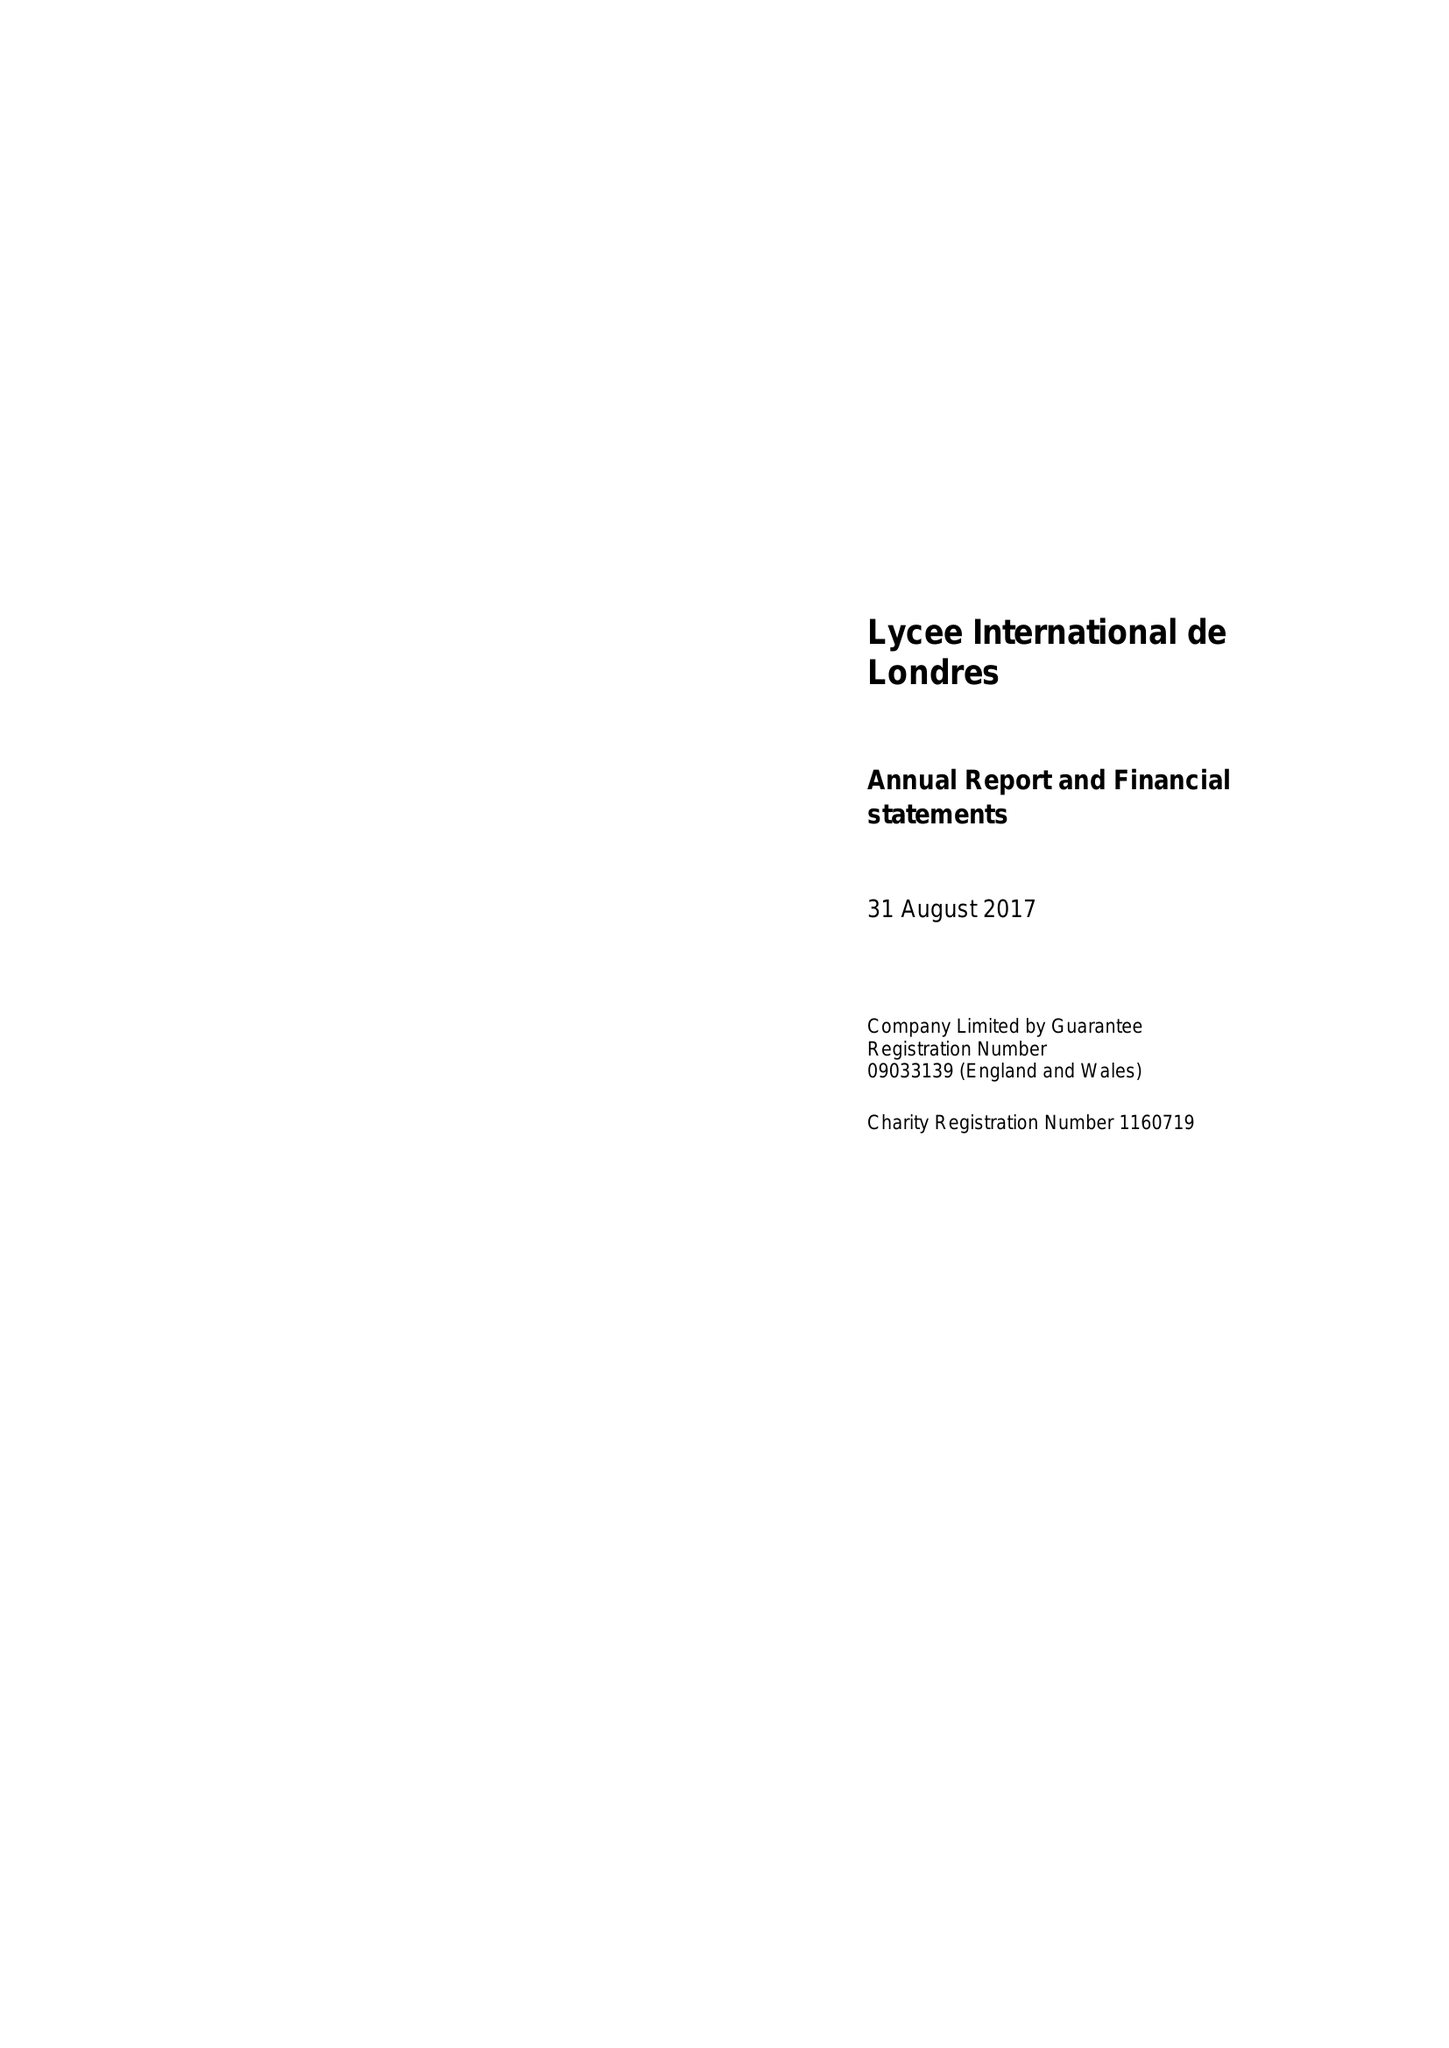What is the value for the report_date?
Answer the question using a single word or phrase. 2017-08-31 